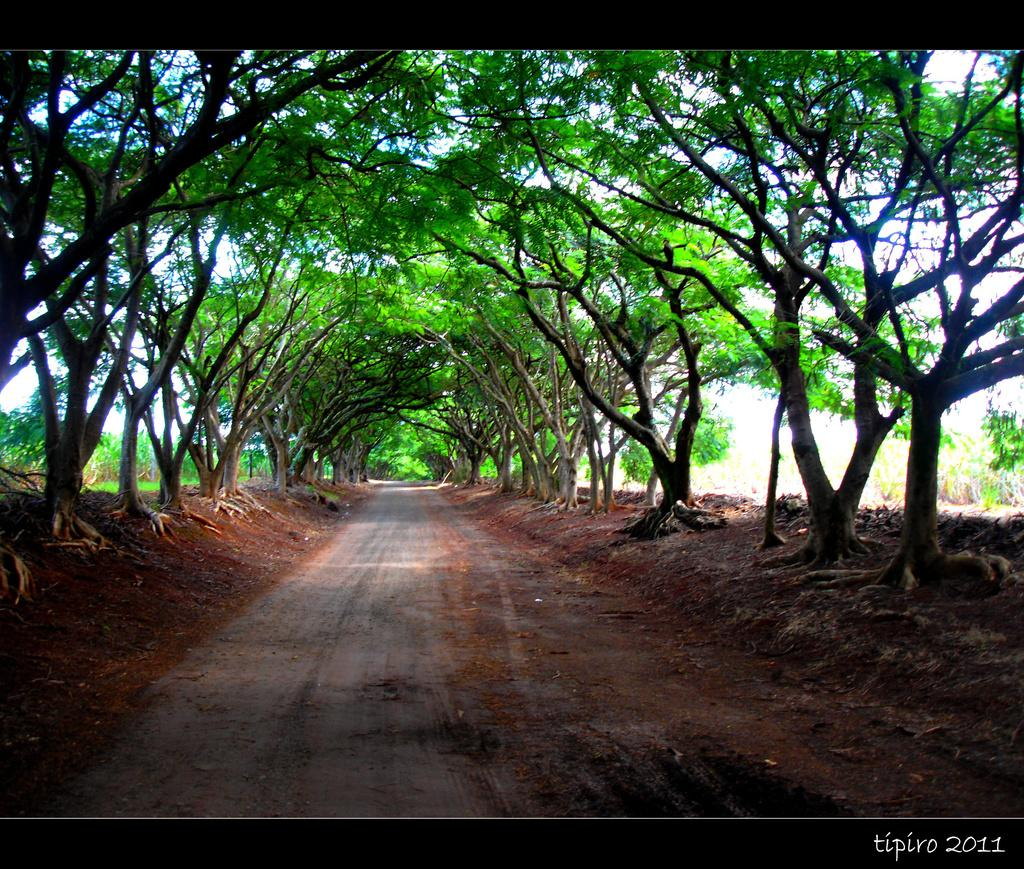What is the main feature in the image? There is a walkway in the image. What can be seen around the walkway? There are many trees around the walkway. What is visible in the background of the image? The sky is visible in the background of the image. What type of iron is being used to cough on the walkway in the image? There is no iron or coughing person present in the image. How is the hose being used in the image? There is no hose present in the image. 